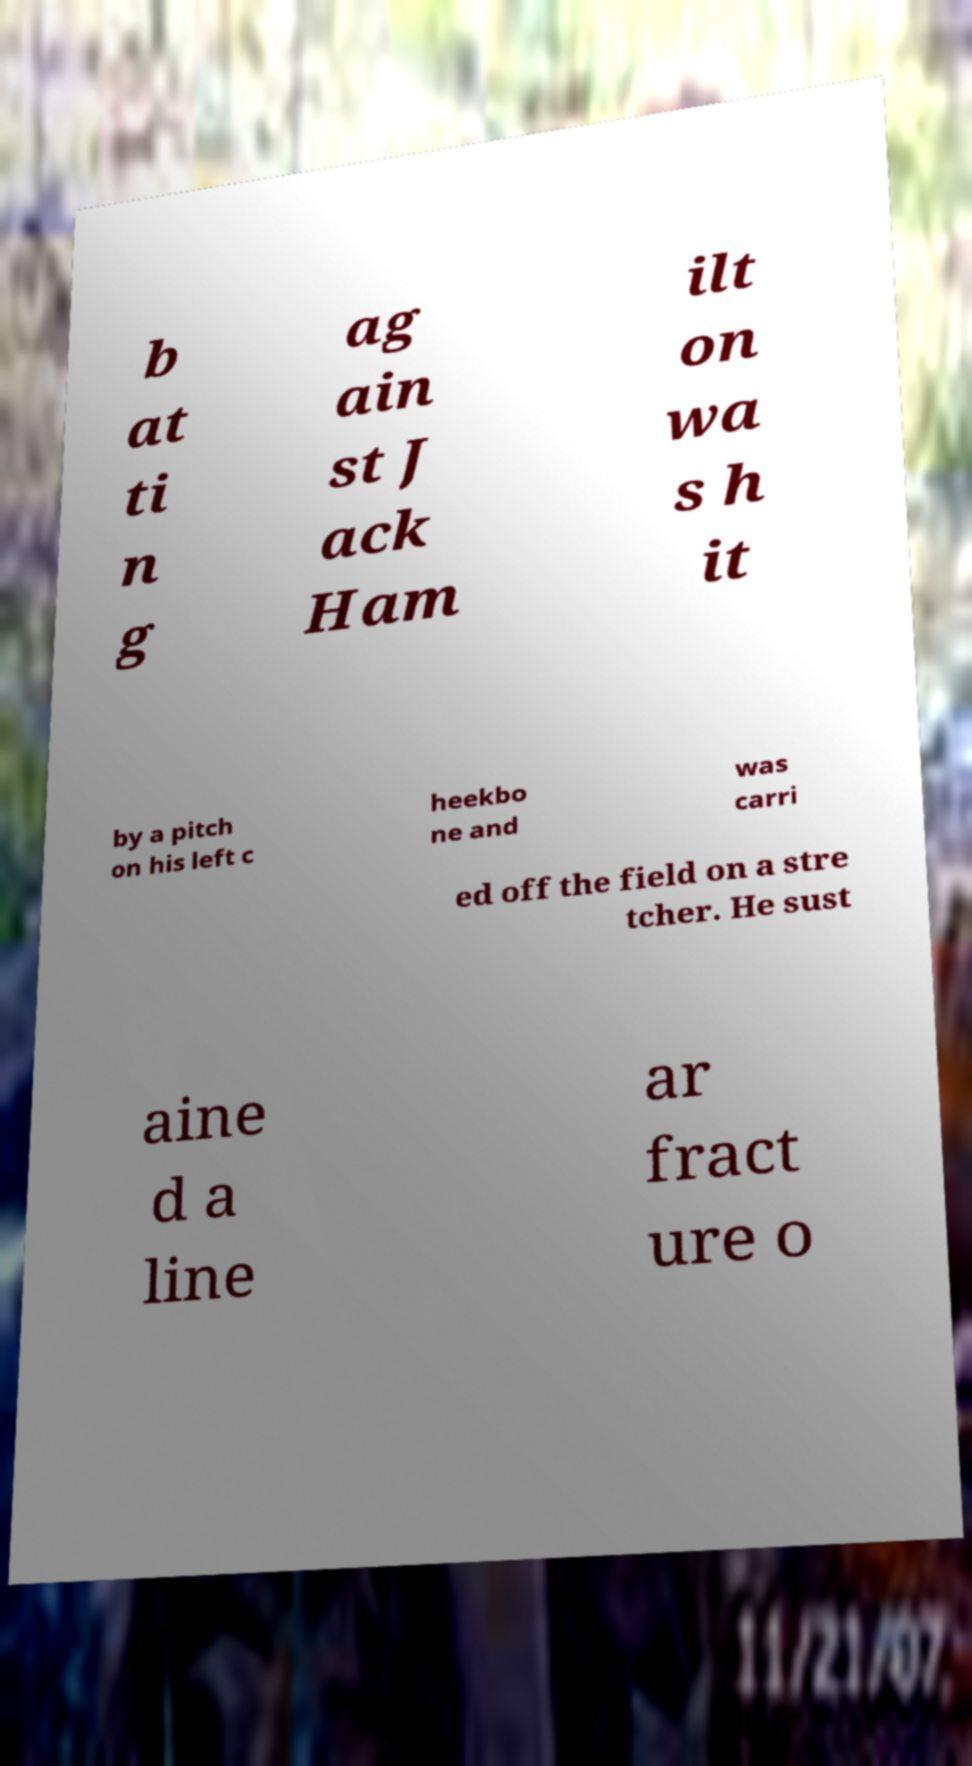Please read and relay the text visible in this image. What does it say? b at ti n g ag ain st J ack Ham ilt on wa s h it by a pitch on his left c heekbo ne and was carri ed off the field on a stre tcher. He sust aine d a line ar fract ure o 